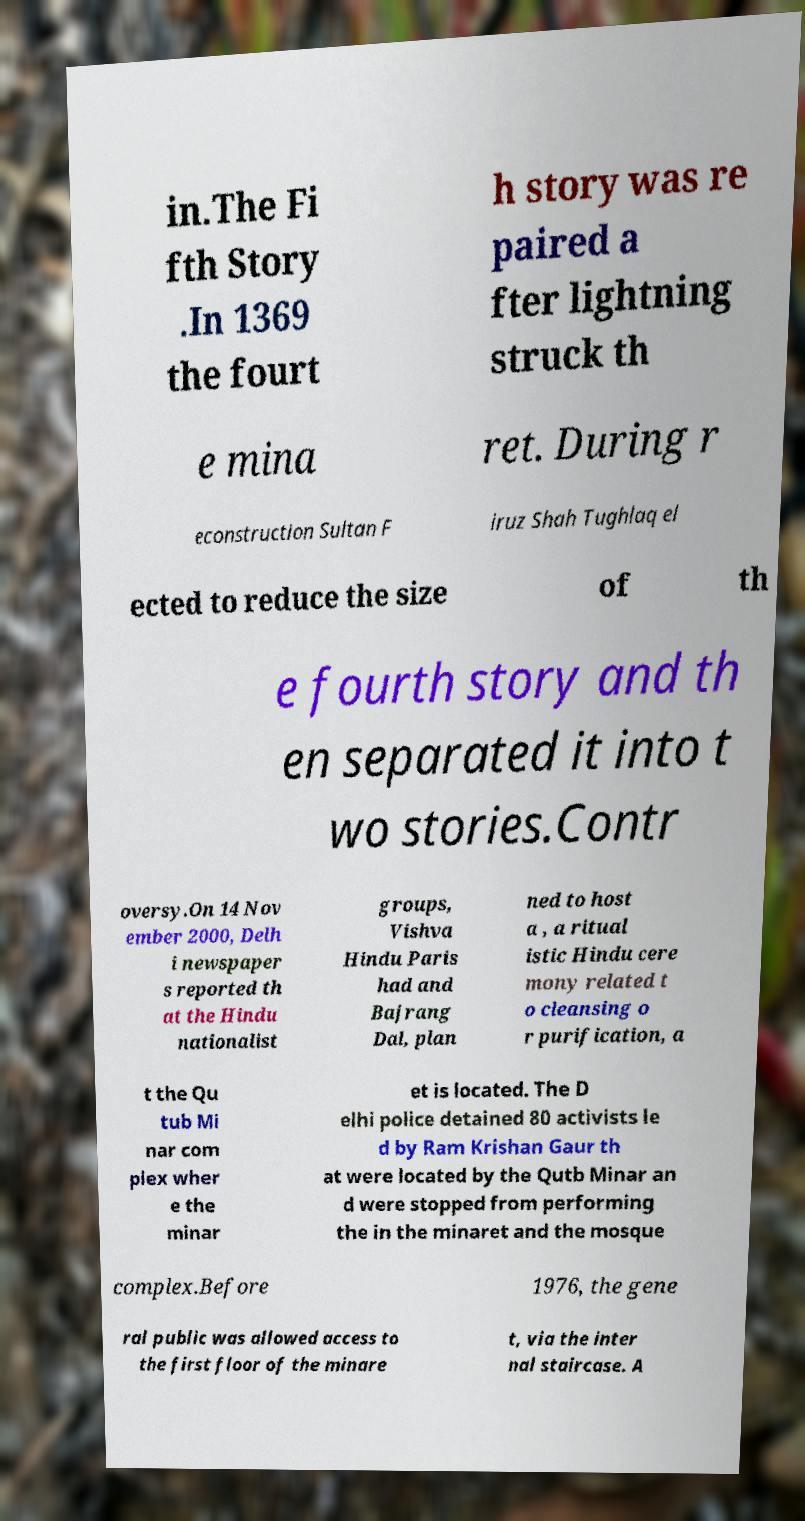There's text embedded in this image that I need extracted. Can you transcribe it verbatim? in.The Fi fth Story .In 1369 the fourt h story was re paired a fter lightning struck th e mina ret. During r econstruction Sultan F iruz Shah Tughlaq el ected to reduce the size of th e fourth story and th en separated it into t wo stories.Contr oversy.On 14 Nov ember 2000, Delh i newspaper s reported th at the Hindu nationalist groups, Vishva Hindu Paris had and Bajrang Dal, plan ned to host a , a ritual istic Hindu cere mony related t o cleansing o r purification, a t the Qu tub Mi nar com plex wher e the minar et is located. The D elhi police detained 80 activists le d by Ram Krishan Gaur th at were located by the Qutb Minar an d were stopped from performing the in the minaret and the mosque complex.Before 1976, the gene ral public was allowed access to the first floor of the minare t, via the inter nal staircase. A 